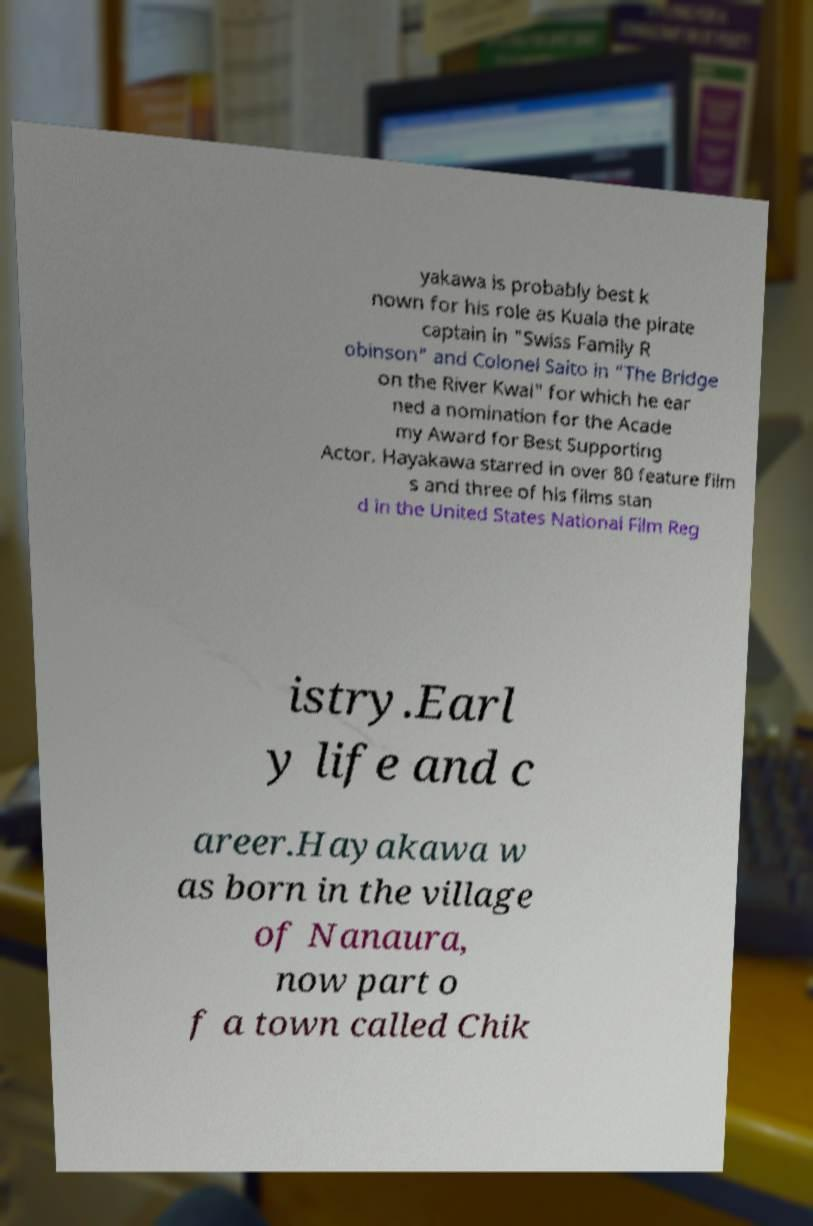Could you extract and type out the text from this image? yakawa is probably best k nown for his role as Kuala the pirate captain in "Swiss Family R obinson" and Colonel Saito in "The Bridge on the River Kwai" for which he ear ned a nomination for the Acade my Award for Best Supporting Actor. Hayakawa starred in over 80 feature film s and three of his films stan d in the United States National Film Reg istry.Earl y life and c areer.Hayakawa w as born in the village of Nanaura, now part o f a town called Chik 